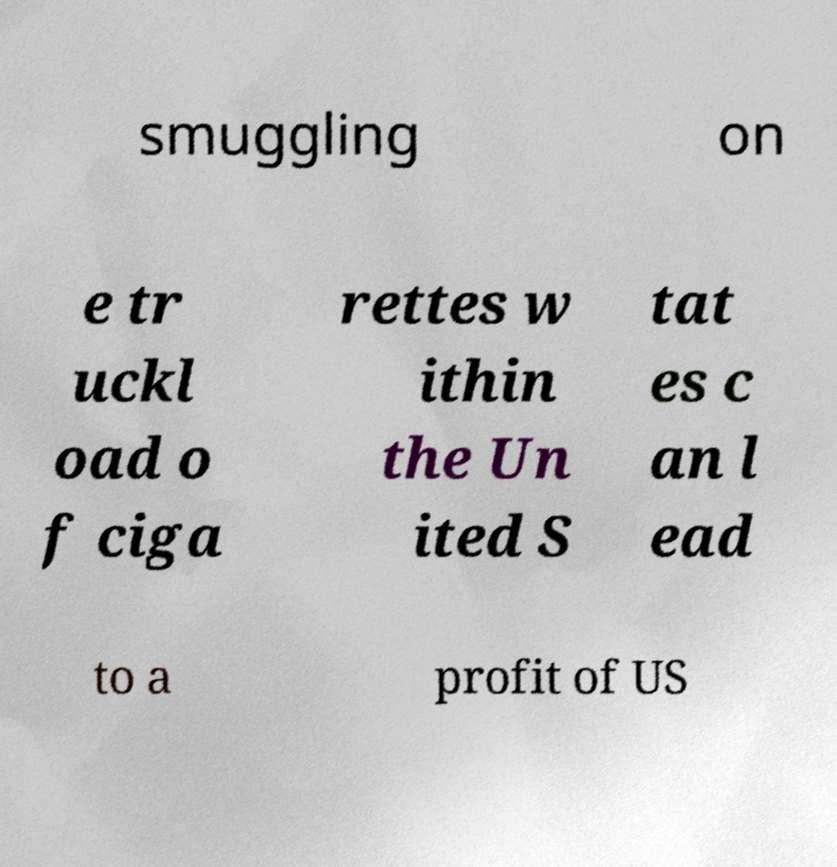There's text embedded in this image that I need extracted. Can you transcribe it verbatim? smuggling on e tr uckl oad o f ciga rettes w ithin the Un ited S tat es c an l ead to a profit of US 